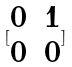Convert formula to latex. <formula><loc_0><loc_0><loc_500><loc_500>[ \begin{matrix} 0 & 1 \\ 0 & 0 \end{matrix} ]</formula> 